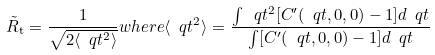<formula> <loc_0><loc_0><loc_500><loc_500>\tilde { R } _ { \mathrm t } = \frac { 1 } { \sqrt { 2 \langle \ q t ^ { 2 } \rangle } } { w h e r e } \langle \ q t ^ { 2 } \rangle = \frac { \int \ q t ^ { 2 } [ C ^ { \prime } ( \ q t , 0 , 0 ) - 1 ] d \ q t } { \int [ C ^ { \prime } ( \ q t , 0 , 0 ) - 1 ] d \ q t }</formula> 